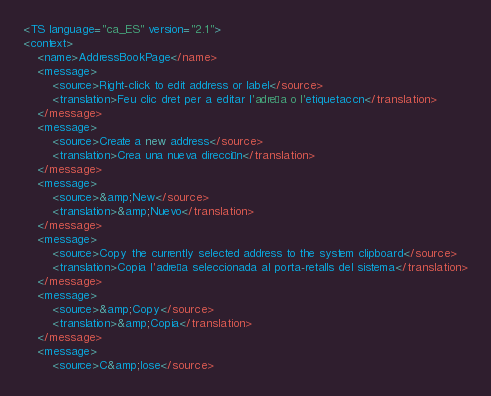<code> <loc_0><loc_0><loc_500><loc_500><_TypeScript_><TS language="ca_ES" version="2.1">
<context>
    <name>AddressBookPage</name>
    <message>
        <source>Right-click to edit address or label</source>
        <translation>Feu clic dret per a editar l'adreça o l'etiquetaccn</translation>
    </message>
    <message>
        <source>Create a new address</source>
        <translation>Crea una nueva dirección</translation>
    </message>
    <message>
        <source>&amp;New</source>
        <translation>&amp;Nuevo</translation>
    </message>
    <message>
        <source>Copy the currently selected address to the system clipboard</source>
        <translation>Copia l'adreça seleccionada al porta-retalls del sistema</translation>
    </message>
    <message>
        <source>&amp;Copy</source>
        <translation>&amp;Copia</translation>
    </message>
    <message>
        <source>C&amp;lose</source></code> 